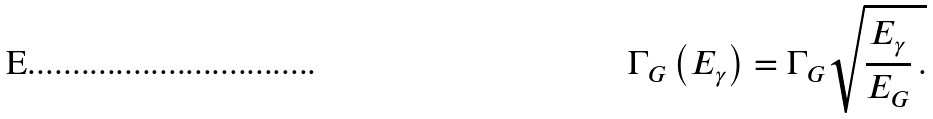Convert formula to latex. <formula><loc_0><loc_0><loc_500><loc_500>\Gamma _ { G } \left ( E _ { \gamma } \right ) = \Gamma _ { G } \sqrt { \frac { E _ { \gamma } } { E _ { G } } \, . }</formula> 